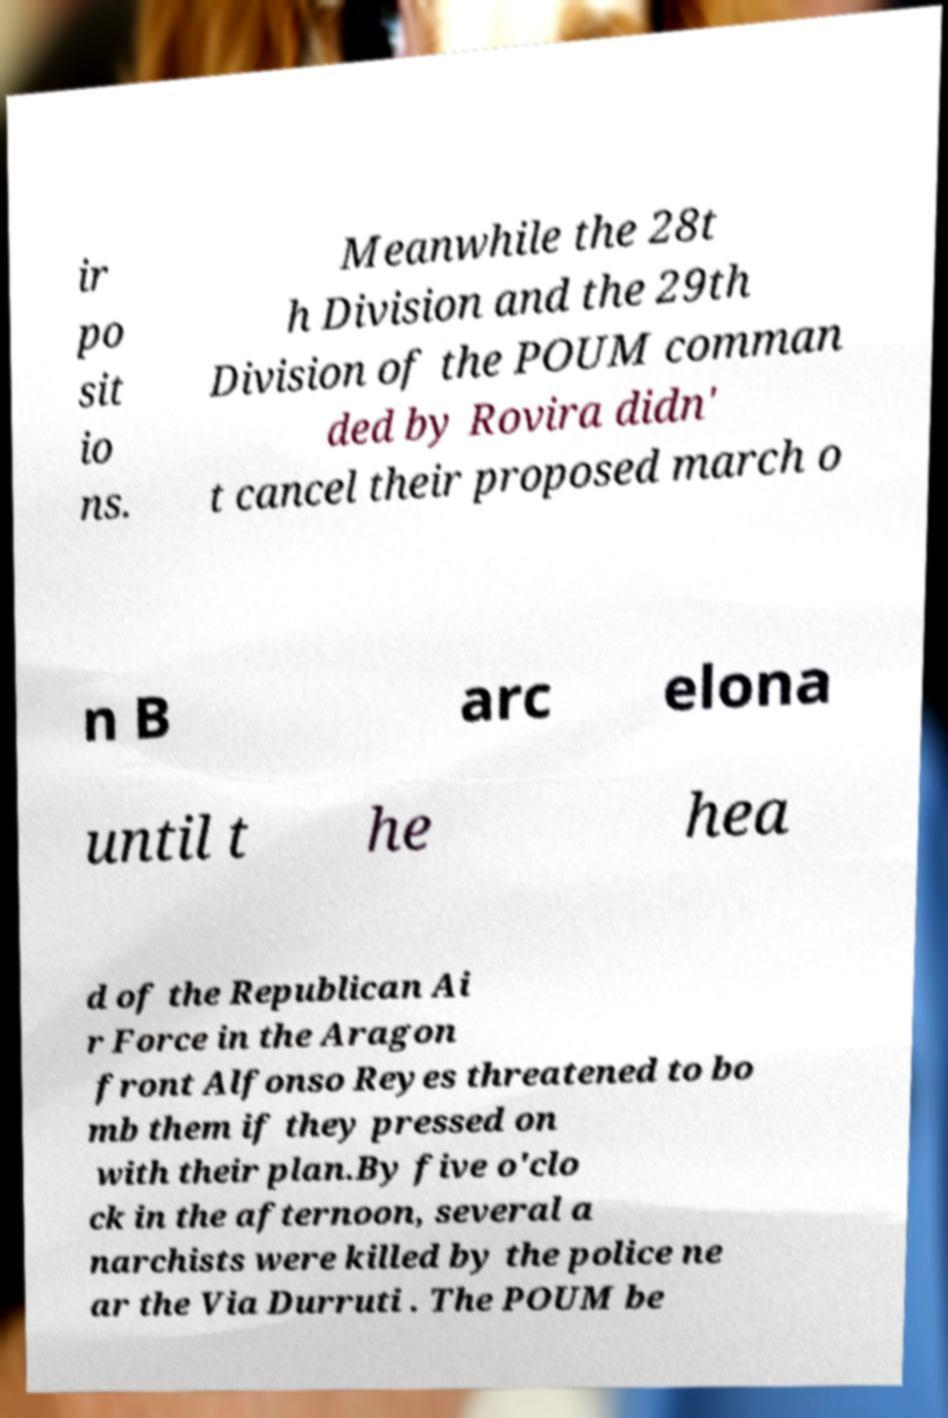Please identify and transcribe the text found in this image. ir po sit io ns. Meanwhile the 28t h Division and the 29th Division of the POUM comman ded by Rovira didn' t cancel their proposed march o n B arc elona until t he hea d of the Republican Ai r Force in the Aragon front Alfonso Reyes threatened to bo mb them if they pressed on with their plan.By five o'clo ck in the afternoon, several a narchists were killed by the police ne ar the Via Durruti . The POUM be 